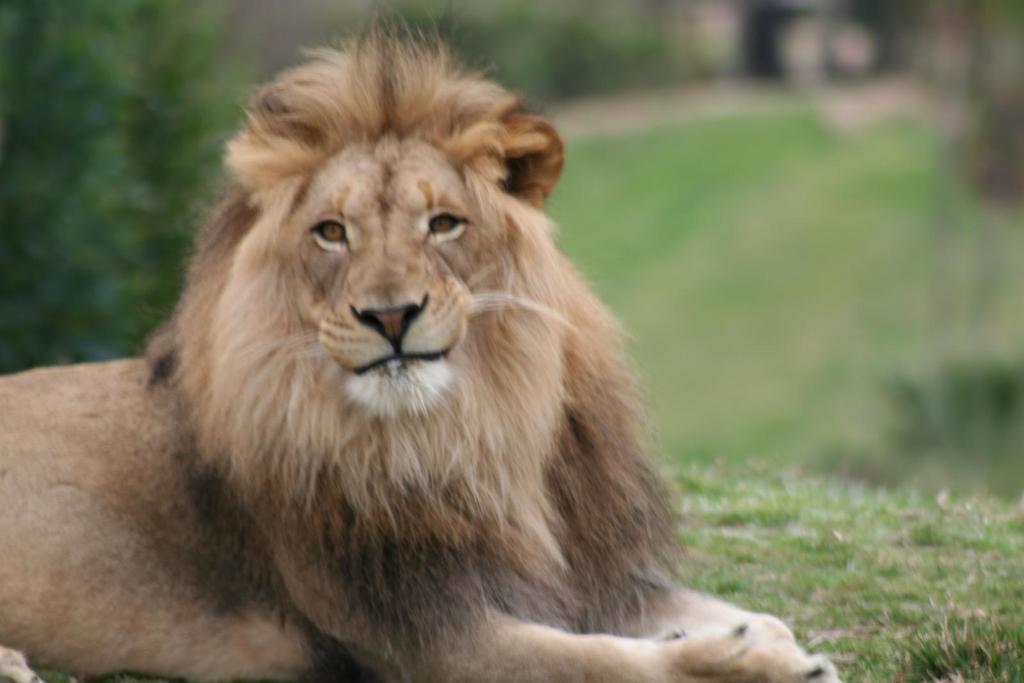What type of animal is in the image? There is a lion in the image. What type of vegetation is visible in the image? There is grass in the image. What other natural element is present in the image? There is a tree in the image. How would you describe the background of the image? The background of the image is blurred. Can you tell me how many rivers are visible in the image? There are no rivers visible in the image. What type of cable can be seen connecting the lion to the tree? There is no cable present in the image. 